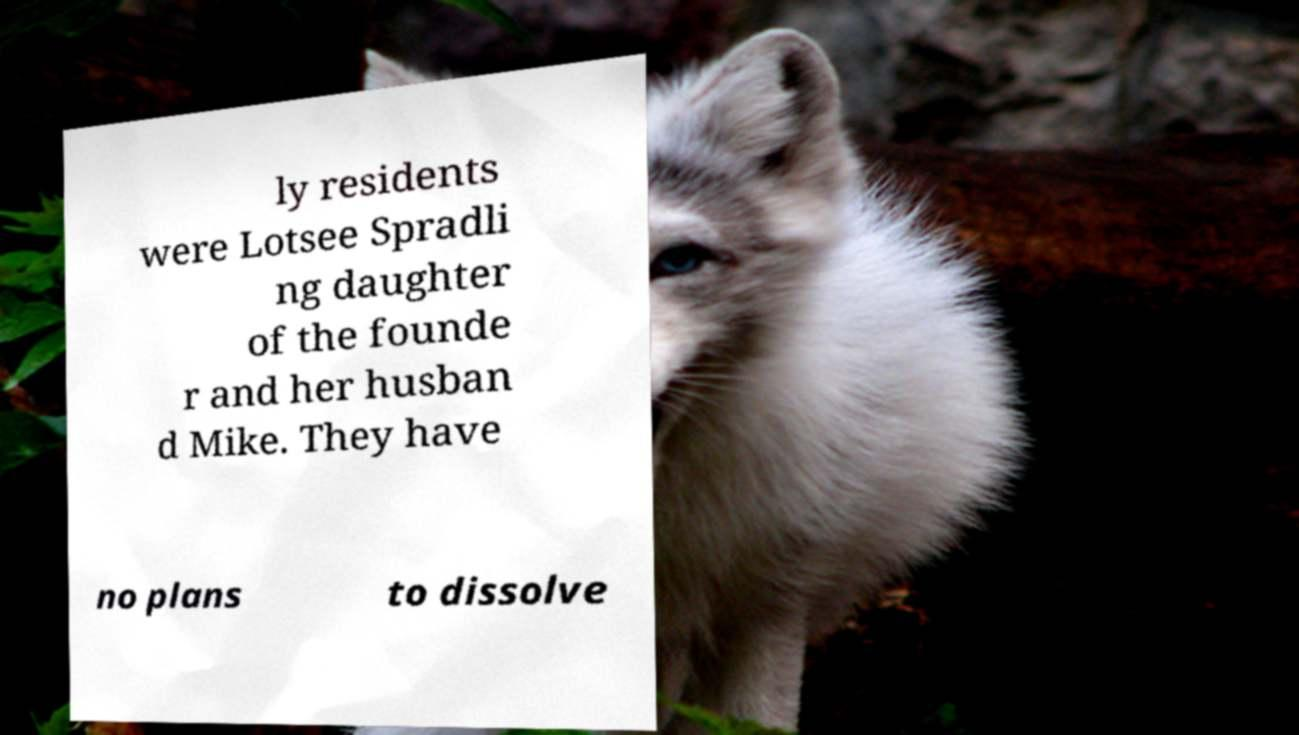Please identify and transcribe the text found in this image. ly residents were Lotsee Spradli ng daughter of the founde r and her husban d Mike. They have no plans to dissolve 